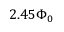Convert formula to latex. <formula><loc_0><loc_0><loc_500><loc_500>2 . 4 5 \Phi _ { 0 }</formula> 